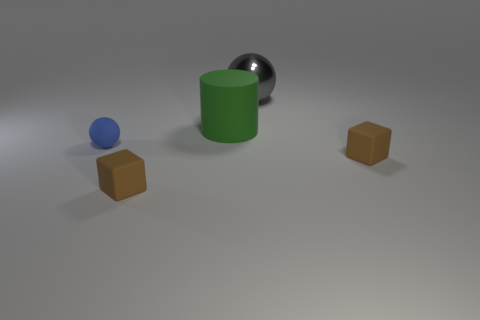Add 4 gray shiny objects. How many objects exist? 9 Subtract all cylinders. How many objects are left? 4 Add 4 balls. How many balls are left? 6 Add 1 large blue balls. How many large blue balls exist? 1 Subtract 0 yellow balls. How many objects are left? 5 Subtract all tiny matte cylinders. Subtract all big gray metal balls. How many objects are left? 4 